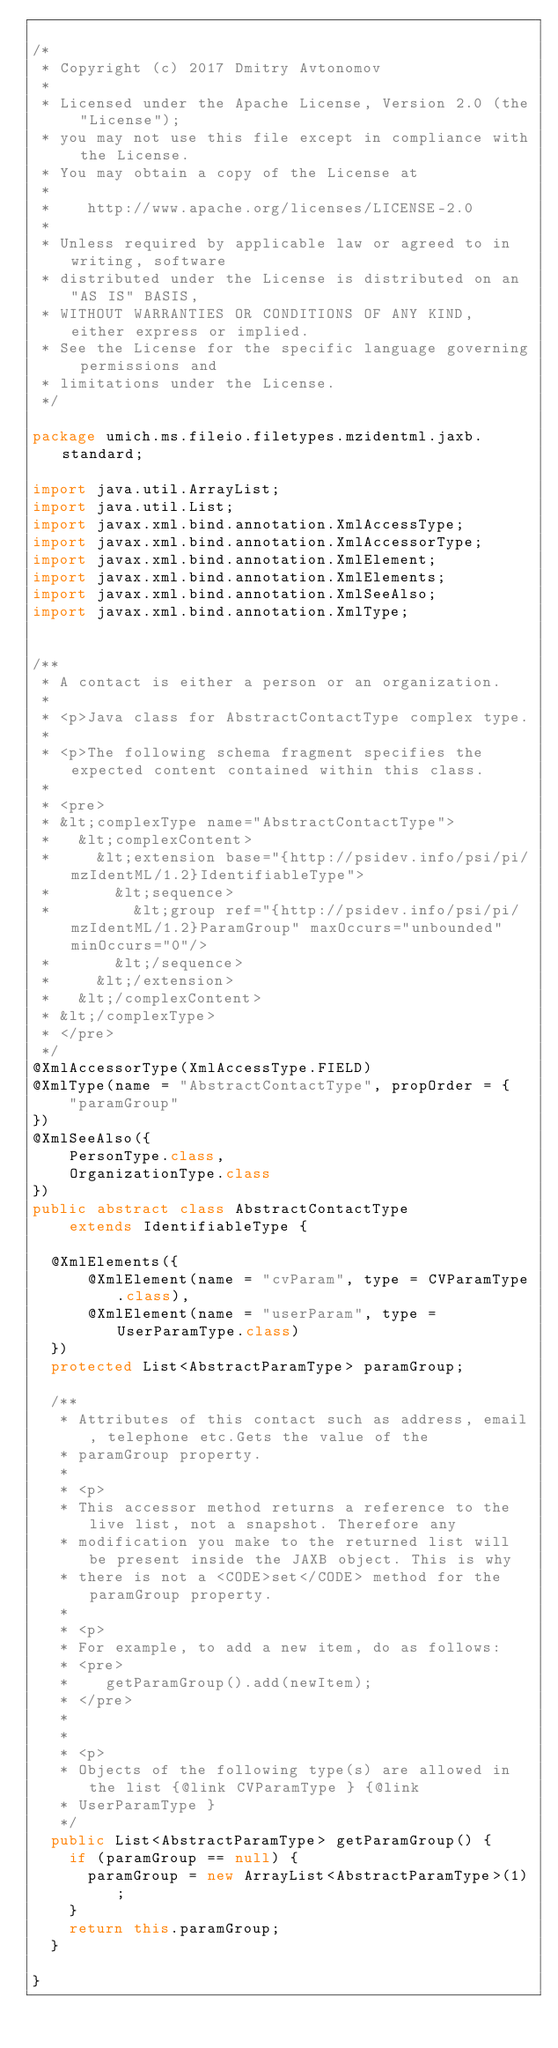<code> <loc_0><loc_0><loc_500><loc_500><_Java_>
/*
 * Copyright (c) 2017 Dmitry Avtonomov
 *
 * Licensed under the Apache License, Version 2.0 (the "License");
 * you may not use this file except in compliance with the License.
 * You may obtain a copy of the License at
 *
 *    http://www.apache.org/licenses/LICENSE-2.0
 *
 * Unless required by applicable law or agreed to in writing, software
 * distributed under the License is distributed on an "AS IS" BASIS,
 * WITHOUT WARRANTIES OR CONDITIONS OF ANY KIND, either express or implied.
 * See the License for the specific language governing permissions and
 * limitations under the License.
 */

package umich.ms.fileio.filetypes.mzidentml.jaxb.standard;

import java.util.ArrayList;
import java.util.List;
import javax.xml.bind.annotation.XmlAccessType;
import javax.xml.bind.annotation.XmlAccessorType;
import javax.xml.bind.annotation.XmlElement;
import javax.xml.bind.annotation.XmlElements;
import javax.xml.bind.annotation.XmlSeeAlso;
import javax.xml.bind.annotation.XmlType;


/**
 * A contact is either a person or an organization.
 *
 * <p>Java class for AbstractContactType complex type.
 *
 * <p>The following schema fragment specifies the expected content contained within this class.
 *
 * <pre>
 * &lt;complexType name="AbstractContactType">
 *   &lt;complexContent>
 *     &lt;extension base="{http://psidev.info/psi/pi/mzIdentML/1.2}IdentifiableType">
 *       &lt;sequence>
 *         &lt;group ref="{http://psidev.info/psi/pi/mzIdentML/1.2}ParamGroup" maxOccurs="unbounded" minOccurs="0"/>
 *       &lt;/sequence>
 *     &lt;/extension>
 *   &lt;/complexContent>
 * &lt;/complexType>
 * </pre>
 */
@XmlAccessorType(XmlAccessType.FIELD)
@XmlType(name = "AbstractContactType", propOrder = {
    "paramGroup"
})
@XmlSeeAlso({
    PersonType.class,
    OrganizationType.class
})
public abstract class AbstractContactType
    extends IdentifiableType {

  @XmlElements({
      @XmlElement(name = "cvParam", type = CVParamType.class),
      @XmlElement(name = "userParam", type = UserParamType.class)
  })
  protected List<AbstractParamType> paramGroup;

  /**
   * Attributes of this contact such as address, email, telephone etc.Gets the value of the
   * paramGroup property.
   *
   * <p>
   * This accessor method returns a reference to the live list, not a snapshot. Therefore any
   * modification you make to the returned list will be present inside the JAXB object. This is why
   * there is not a <CODE>set</CODE> method for the paramGroup property.
   *
   * <p>
   * For example, to add a new item, do as follows:
   * <pre>
   *    getParamGroup().add(newItem);
   * </pre>
   *
   *
   * <p>
   * Objects of the following type(s) are allowed in the list {@link CVParamType } {@link
   * UserParamType }
   */
  public List<AbstractParamType> getParamGroup() {
    if (paramGroup == null) {
      paramGroup = new ArrayList<AbstractParamType>(1);
    }
    return this.paramGroup;
  }

}
</code> 